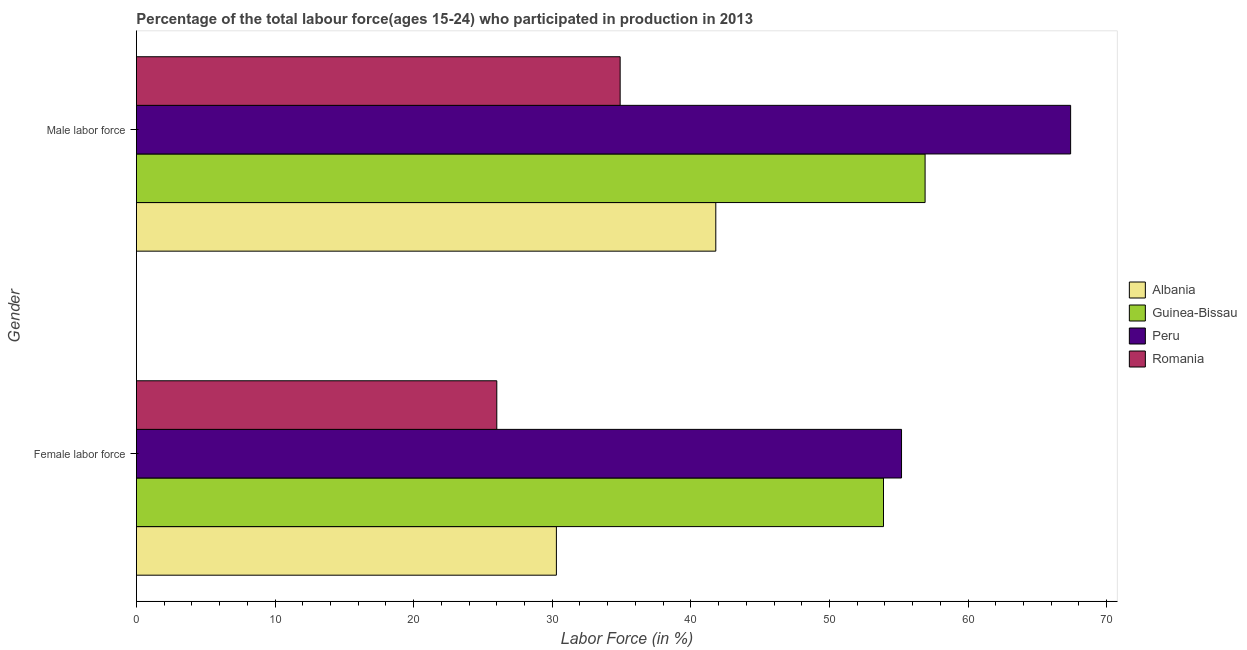How many different coloured bars are there?
Give a very brief answer. 4. How many groups of bars are there?
Ensure brevity in your answer.  2. Are the number of bars on each tick of the Y-axis equal?
Ensure brevity in your answer.  Yes. What is the label of the 1st group of bars from the top?
Offer a very short reply. Male labor force. What is the percentage of male labour force in Albania?
Your answer should be compact. 41.8. Across all countries, what is the maximum percentage of female labor force?
Provide a succinct answer. 55.2. Across all countries, what is the minimum percentage of male labour force?
Offer a very short reply. 34.9. In which country was the percentage of male labour force minimum?
Keep it short and to the point. Romania. What is the total percentage of male labour force in the graph?
Make the answer very short. 201. What is the difference between the percentage of male labour force in Romania and that in Peru?
Make the answer very short. -32.5. What is the difference between the percentage of female labor force in Peru and the percentage of male labour force in Albania?
Your response must be concise. 13.4. What is the average percentage of male labour force per country?
Provide a short and direct response. 50.25. What is the difference between the percentage of female labor force and percentage of male labour force in Peru?
Your answer should be compact. -12.2. What is the ratio of the percentage of male labour force in Romania to that in Albania?
Provide a succinct answer. 0.83. Is the percentage of female labor force in Peru less than that in Romania?
Your response must be concise. No. What does the 1st bar from the top in Male labor force represents?
Keep it short and to the point. Romania. What does the 4th bar from the bottom in Female labor force represents?
Make the answer very short. Romania. How many bars are there?
Provide a short and direct response. 8. Are all the bars in the graph horizontal?
Provide a succinct answer. Yes. What is the difference between two consecutive major ticks on the X-axis?
Your answer should be very brief. 10. What is the title of the graph?
Make the answer very short. Percentage of the total labour force(ages 15-24) who participated in production in 2013. Does "Germany" appear as one of the legend labels in the graph?
Your answer should be compact. No. What is the label or title of the X-axis?
Offer a very short reply. Labor Force (in %). What is the label or title of the Y-axis?
Give a very brief answer. Gender. What is the Labor Force (in %) of Albania in Female labor force?
Keep it short and to the point. 30.3. What is the Labor Force (in %) in Guinea-Bissau in Female labor force?
Your response must be concise. 53.9. What is the Labor Force (in %) in Peru in Female labor force?
Ensure brevity in your answer.  55.2. What is the Labor Force (in %) of Romania in Female labor force?
Offer a terse response. 26. What is the Labor Force (in %) of Albania in Male labor force?
Provide a succinct answer. 41.8. What is the Labor Force (in %) of Guinea-Bissau in Male labor force?
Your response must be concise. 56.9. What is the Labor Force (in %) in Peru in Male labor force?
Your answer should be compact. 67.4. What is the Labor Force (in %) in Romania in Male labor force?
Your answer should be very brief. 34.9. Across all Gender, what is the maximum Labor Force (in %) of Albania?
Provide a short and direct response. 41.8. Across all Gender, what is the maximum Labor Force (in %) of Guinea-Bissau?
Your response must be concise. 56.9. Across all Gender, what is the maximum Labor Force (in %) in Peru?
Provide a succinct answer. 67.4. Across all Gender, what is the maximum Labor Force (in %) of Romania?
Your answer should be compact. 34.9. Across all Gender, what is the minimum Labor Force (in %) of Albania?
Your answer should be very brief. 30.3. Across all Gender, what is the minimum Labor Force (in %) in Guinea-Bissau?
Your response must be concise. 53.9. Across all Gender, what is the minimum Labor Force (in %) in Peru?
Make the answer very short. 55.2. Across all Gender, what is the minimum Labor Force (in %) of Romania?
Your answer should be very brief. 26. What is the total Labor Force (in %) of Albania in the graph?
Offer a terse response. 72.1. What is the total Labor Force (in %) of Guinea-Bissau in the graph?
Offer a terse response. 110.8. What is the total Labor Force (in %) of Peru in the graph?
Offer a terse response. 122.6. What is the total Labor Force (in %) in Romania in the graph?
Your answer should be compact. 60.9. What is the difference between the Labor Force (in %) of Albania in Female labor force and that in Male labor force?
Your answer should be very brief. -11.5. What is the difference between the Labor Force (in %) in Guinea-Bissau in Female labor force and that in Male labor force?
Your answer should be very brief. -3. What is the difference between the Labor Force (in %) in Peru in Female labor force and that in Male labor force?
Offer a very short reply. -12.2. What is the difference between the Labor Force (in %) in Romania in Female labor force and that in Male labor force?
Ensure brevity in your answer.  -8.9. What is the difference between the Labor Force (in %) in Albania in Female labor force and the Labor Force (in %) in Guinea-Bissau in Male labor force?
Your answer should be very brief. -26.6. What is the difference between the Labor Force (in %) of Albania in Female labor force and the Labor Force (in %) of Peru in Male labor force?
Your response must be concise. -37.1. What is the difference between the Labor Force (in %) in Guinea-Bissau in Female labor force and the Labor Force (in %) in Peru in Male labor force?
Provide a succinct answer. -13.5. What is the difference between the Labor Force (in %) of Guinea-Bissau in Female labor force and the Labor Force (in %) of Romania in Male labor force?
Offer a terse response. 19. What is the difference between the Labor Force (in %) in Peru in Female labor force and the Labor Force (in %) in Romania in Male labor force?
Give a very brief answer. 20.3. What is the average Labor Force (in %) of Albania per Gender?
Offer a very short reply. 36.05. What is the average Labor Force (in %) of Guinea-Bissau per Gender?
Your answer should be very brief. 55.4. What is the average Labor Force (in %) of Peru per Gender?
Ensure brevity in your answer.  61.3. What is the average Labor Force (in %) of Romania per Gender?
Keep it short and to the point. 30.45. What is the difference between the Labor Force (in %) in Albania and Labor Force (in %) in Guinea-Bissau in Female labor force?
Offer a terse response. -23.6. What is the difference between the Labor Force (in %) of Albania and Labor Force (in %) of Peru in Female labor force?
Your answer should be compact. -24.9. What is the difference between the Labor Force (in %) in Guinea-Bissau and Labor Force (in %) in Peru in Female labor force?
Keep it short and to the point. -1.3. What is the difference between the Labor Force (in %) in Guinea-Bissau and Labor Force (in %) in Romania in Female labor force?
Keep it short and to the point. 27.9. What is the difference between the Labor Force (in %) of Peru and Labor Force (in %) of Romania in Female labor force?
Offer a very short reply. 29.2. What is the difference between the Labor Force (in %) in Albania and Labor Force (in %) in Guinea-Bissau in Male labor force?
Offer a terse response. -15.1. What is the difference between the Labor Force (in %) in Albania and Labor Force (in %) in Peru in Male labor force?
Offer a terse response. -25.6. What is the difference between the Labor Force (in %) of Guinea-Bissau and Labor Force (in %) of Peru in Male labor force?
Your answer should be very brief. -10.5. What is the difference between the Labor Force (in %) in Peru and Labor Force (in %) in Romania in Male labor force?
Make the answer very short. 32.5. What is the ratio of the Labor Force (in %) of Albania in Female labor force to that in Male labor force?
Offer a terse response. 0.72. What is the ratio of the Labor Force (in %) in Guinea-Bissau in Female labor force to that in Male labor force?
Provide a succinct answer. 0.95. What is the ratio of the Labor Force (in %) of Peru in Female labor force to that in Male labor force?
Give a very brief answer. 0.82. What is the ratio of the Labor Force (in %) in Romania in Female labor force to that in Male labor force?
Ensure brevity in your answer.  0.74. What is the difference between the highest and the second highest Labor Force (in %) in Albania?
Your response must be concise. 11.5. What is the difference between the highest and the second highest Labor Force (in %) in Romania?
Make the answer very short. 8.9. What is the difference between the highest and the lowest Labor Force (in %) in Albania?
Ensure brevity in your answer.  11.5. What is the difference between the highest and the lowest Labor Force (in %) of Guinea-Bissau?
Ensure brevity in your answer.  3. What is the difference between the highest and the lowest Labor Force (in %) of Romania?
Give a very brief answer. 8.9. 